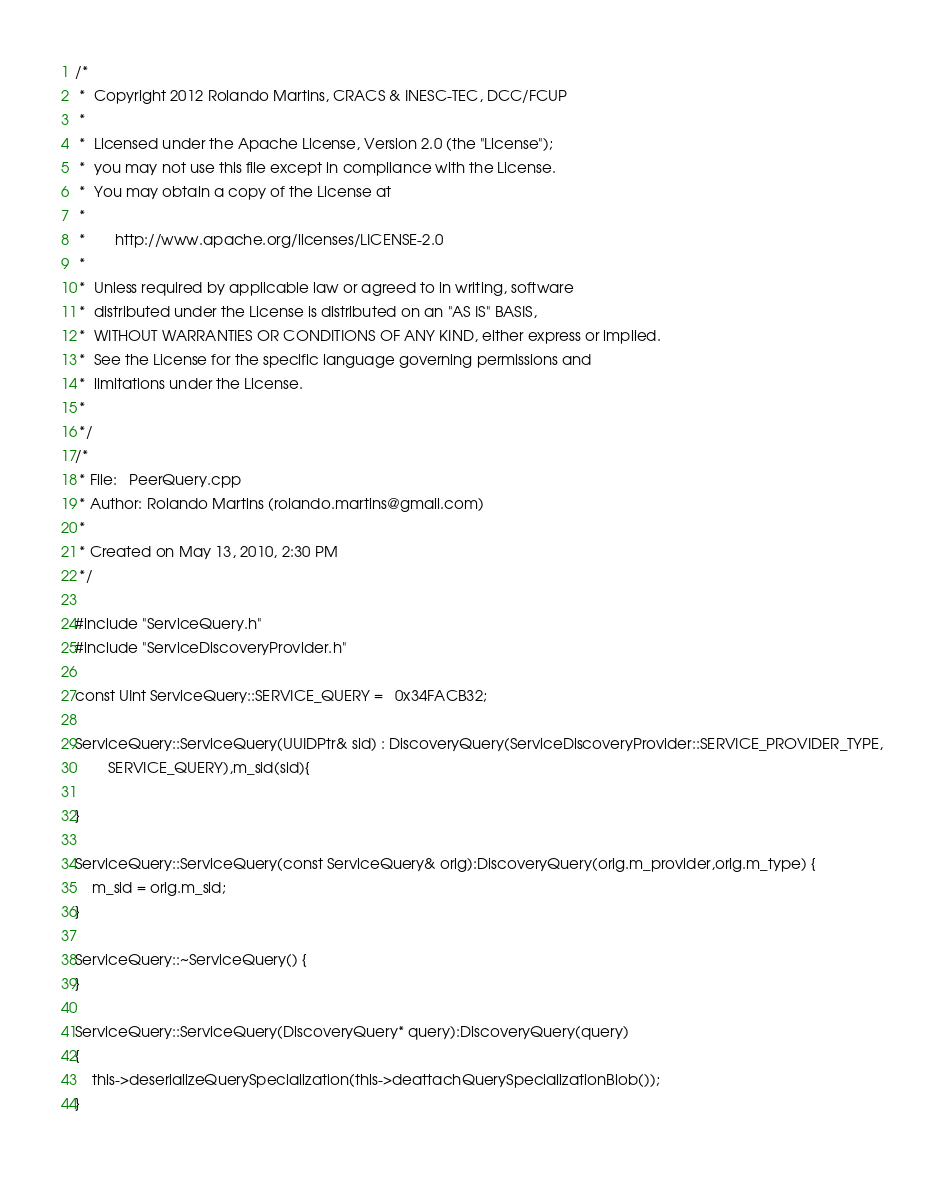Convert code to text. <code><loc_0><loc_0><loc_500><loc_500><_C++_>/*
 *  Copyright 2012 Rolando Martins, CRACS & INESC-TEC, DCC/FCUP
 *
 *  Licensed under the Apache License, Version 2.0 (the "License");
 *  you may not use this file except in compliance with the License.
 *  You may obtain a copy of the License at
 *   
 *       http://www.apache.org/licenses/LICENSE-2.0
 *
 *  Unless required by applicable law or agreed to in writing, software
 *  distributed under the License is distributed on an "AS IS" BASIS,
 *  WITHOUT WARRANTIES OR CONDITIONS OF ANY KIND, either express or implied.
 *  See the License for the specific language governing permissions and
 *  limitations under the License.
 * 
 */
/* 
 * File:   PeerQuery.cpp
 * Author: Rolando Martins (rolando.martins@gmail.com)
 * 
 * Created on May 13, 2010, 2:30 PM
 */

#include "ServiceQuery.h"
#include "ServiceDiscoveryProvider.h"

const UInt ServiceQuery::SERVICE_QUERY =   0x34FACB32;

ServiceQuery::ServiceQuery(UUIDPtr& sid) : DiscoveryQuery(ServiceDiscoveryProvider::SERVICE_PROVIDER_TYPE,
        SERVICE_QUERY),m_sid(sid){
    
}

ServiceQuery::ServiceQuery(const ServiceQuery& orig):DiscoveryQuery(orig.m_provider,orig.m_type) {
    m_sid = orig.m_sid;
}

ServiceQuery::~ServiceQuery() {    
}

ServiceQuery::ServiceQuery(DiscoveryQuery* query):DiscoveryQuery(query)
{
    this->deserializeQuerySpecialization(this->deattachQuerySpecializationBlob());
}</code> 